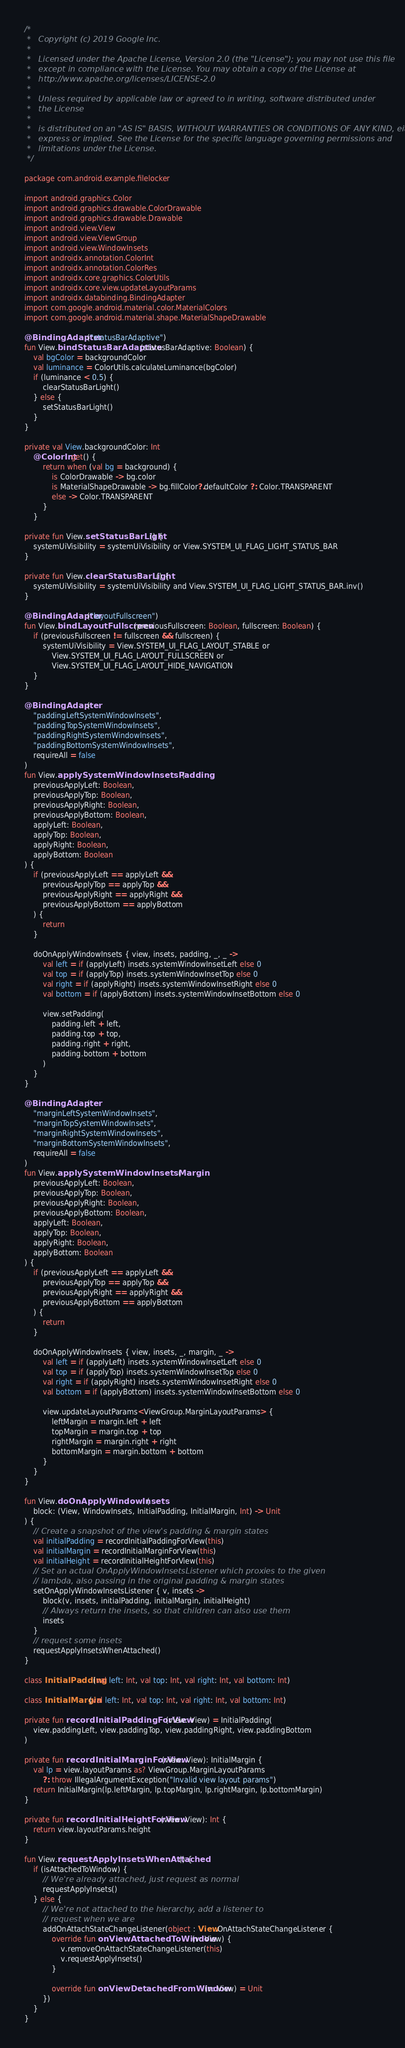Convert code to text. <code><loc_0><loc_0><loc_500><loc_500><_Kotlin_>/*
 *   Copyright (c) 2019 Google Inc.
 *
 *   Licensed under the Apache License, Version 2.0 (the "License"); you may not use this file
 *   except in compliance with the License. You may obtain a copy of the License at
 *   http://www.apache.org/licenses/LICENSE-2.0
 *
 *   Unless required by applicable law or agreed to in writing, software distributed under
 *   the License
 *
 *   is distributed on an "AS IS" BASIS, WITHOUT WARRANTIES OR CONDITIONS OF ANY KIND, either
 *   express or implied. See the License for the specific language governing permissions and
 *   limitations under the License.
 */

package com.android.example.filelocker

import android.graphics.Color
import android.graphics.drawable.ColorDrawable
import android.graphics.drawable.Drawable
import android.view.View
import android.view.ViewGroup
import android.view.WindowInsets
import androidx.annotation.ColorInt
import androidx.annotation.ColorRes
import androidx.core.graphics.ColorUtils
import androidx.core.view.updateLayoutParams
import androidx.databinding.BindingAdapter
import com.google.android.material.color.MaterialColors
import com.google.android.material.shape.MaterialShapeDrawable

@BindingAdapter("statusBarAdaptive")
fun View.bindStatusBarAdaptive(statusBarAdaptive: Boolean) {
    val bgColor = backgroundColor
    val luminance = ColorUtils.calculateLuminance(bgColor)
    if (luminance < 0.5) {
        clearStatusBarLight()
    } else {
        setStatusBarLight()
    }
}

private val View.backgroundColor: Int
    @ColorInt get() {
        return when (val bg = background) {
            is ColorDrawable -> bg.color
            is MaterialShapeDrawable -> bg.fillColor?.defaultColor ?: Color.TRANSPARENT
            else -> Color.TRANSPARENT
        }
    }

private fun View.setStatusBarLight() {
    systemUiVisibility = systemUiVisibility or View.SYSTEM_UI_FLAG_LIGHT_STATUS_BAR
}

private fun View.clearStatusBarLight() {
    systemUiVisibility = systemUiVisibility and View.SYSTEM_UI_FLAG_LIGHT_STATUS_BAR.inv()
}

@BindingAdapter("layoutFullscreen")
fun View.bindLayoutFullscreen(previousFullscreen: Boolean, fullscreen: Boolean) {
    if (previousFullscreen != fullscreen && fullscreen) {
        systemUiVisibility = View.SYSTEM_UI_FLAG_LAYOUT_STABLE or
            View.SYSTEM_UI_FLAG_LAYOUT_FULLSCREEN or
            View.SYSTEM_UI_FLAG_LAYOUT_HIDE_NAVIGATION
    }
}

@BindingAdapter(
    "paddingLeftSystemWindowInsets",
    "paddingTopSystemWindowInsets",
    "paddingRightSystemWindowInsets",
    "paddingBottomSystemWindowInsets",
    requireAll = false
)
fun View.applySystemWindowInsetsPadding(
    previousApplyLeft: Boolean,
    previousApplyTop: Boolean,
    previousApplyRight: Boolean,
    previousApplyBottom: Boolean,
    applyLeft: Boolean,
    applyTop: Boolean,
    applyRight: Boolean,
    applyBottom: Boolean
) {
    if (previousApplyLeft == applyLeft &&
        previousApplyTop == applyTop &&
        previousApplyRight == applyRight &&
        previousApplyBottom == applyBottom
    ) {
        return
    }

    doOnApplyWindowInsets { view, insets, padding, _, _ ->
        val left = if (applyLeft) insets.systemWindowInsetLeft else 0
        val top = if (applyTop) insets.systemWindowInsetTop else 0
        val right = if (applyRight) insets.systemWindowInsetRight else 0
        val bottom = if (applyBottom) insets.systemWindowInsetBottom else 0

        view.setPadding(
            padding.left + left,
            padding.top + top,
            padding.right + right,
            padding.bottom + bottom
        )
    }
}

@BindingAdapter(
    "marginLeftSystemWindowInsets",
    "marginTopSystemWindowInsets",
    "marginRightSystemWindowInsets",
    "marginBottomSystemWindowInsets",
    requireAll = false
)
fun View.applySystemWindowInsetsMargin(
    previousApplyLeft: Boolean,
    previousApplyTop: Boolean,
    previousApplyRight: Boolean,
    previousApplyBottom: Boolean,
    applyLeft: Boolean,
    applyTop: Boolean,
    applyRight: Boolean,
    applyBottom: Boolean
) {
    if (previousApplyLeft == applyLeft &&
        previousApplyTop == applyTop &&
        previousApplyRight == applyRight &&
        previousApplyBottom == applyBottom
    ) {
        return
    }

    doOnApplyWindowInsets { view, insets, _, margin, _ ->
        val left = if (applyLeft) insets.systemWindowInsetLeft else 0
        val top = if (applyTop) insets.systemWindowInsetTop else 0
        val right = if (applyRight) insets.systemWindowInsetRight else 0
        val bottom = if (applyBottom) insets.systemWindowInsetBottom else 0

        view.updateLayoutParams<ViewGroup.MarginLayoutParams> {
            leftMargin = margin.left + left
            topMargin = margin.top + top
            rightMargin = margin.right + right
            bottomMargin = margin.bottom + bottom
        }
    }
}

fun View.doOnApplyWindowInsets(
    block: (View, WindowInsets, InitialPadding, InitialMargin, Int) -> Unit
) {
    // Create a snapshot of the view's padding & margin states
    val initialPadding = recordInitialPaddingForView(this)
    val initialMargin = recordInitialMarginForView(this)
    val initialHeight = recordInitialHeightForView(this)
    // Set an actual OnApplyWindowInsetsListener which proxies to the given
    // lambda, also passing in the original padding & margin states
    setOnApplyWindowInsetsListener { v, insets ->
        block(v, insets, initialPadding, initialMargin, initialHeight)
        // Always return the insets, so that children can also use them
        insets
    }
    // request some insets
    requestApplyInsetsWhenAttached()
}

class InitialPadding(val left: Int, val top: Int, val right: Int, val bottom: Int)

class InitialMargin(val left: Int, val top: Int, val right: Int, val bottom: Int)

private fun recordInitialPaddingForView(view: View) = InitialPadding(
    view.paddingLeft, view.paddingTop, view.paddingRight, view.paddingBottom
)

private fun recordInitialMarginForView(view: View): InitialMargin {
    val lp = view.layoutParams as? ViewGroup.MarginLayoutParams
        ?: throw IllegalArgumentException("Invalid view layout params")
    return InitialMargin(lp.leftMargin, lp.topMargin, lp.rightMargin, lp.bottomMargin)
}

private fun recordInitialHeightForView(view: View): Int {
    return view.layoutParams.height
}

fun View.requestApplyInsetsWhenAttached() {
    if (isAttachedToWindow) {
        // We're already attached, just request as normal
        requestApplyInsets()
    } else {
        // We're not attached to the hierarchy, add a listener to
        // request when we are
        addOnAttachStateChangeListener(object : View.OnAttachStateChangeListener {
            override fun onViewAttachedToWindow(v: View) {
                v.removeOnAttachStateChangeListener(this)
                v.requestApplyInsets()
            }

            override fun onViewDetachedFromWindow(v: View) = Unit
        })
    }
}</code> 